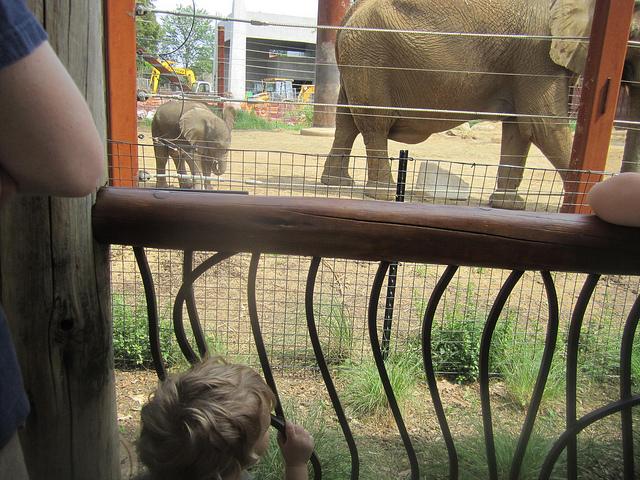What animals are in the image?
Write a very short answer. Elephants. Is the child transfixed with the elephants?
Short answer required. Yes. Is this a mature elephant?
Answer briefly. Yes. What types of vehicles are visible in the background of this scene?
Short answer required. Construction vehicles. 